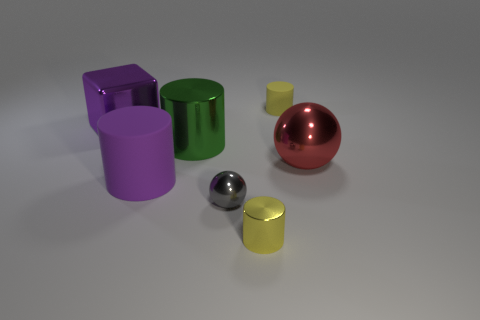Is there a gray thing of the same shape as the yellow rubber object? No, there is not a gray object with the exact same shape as the yellow rubber object. All objects present have distinct shapes. 